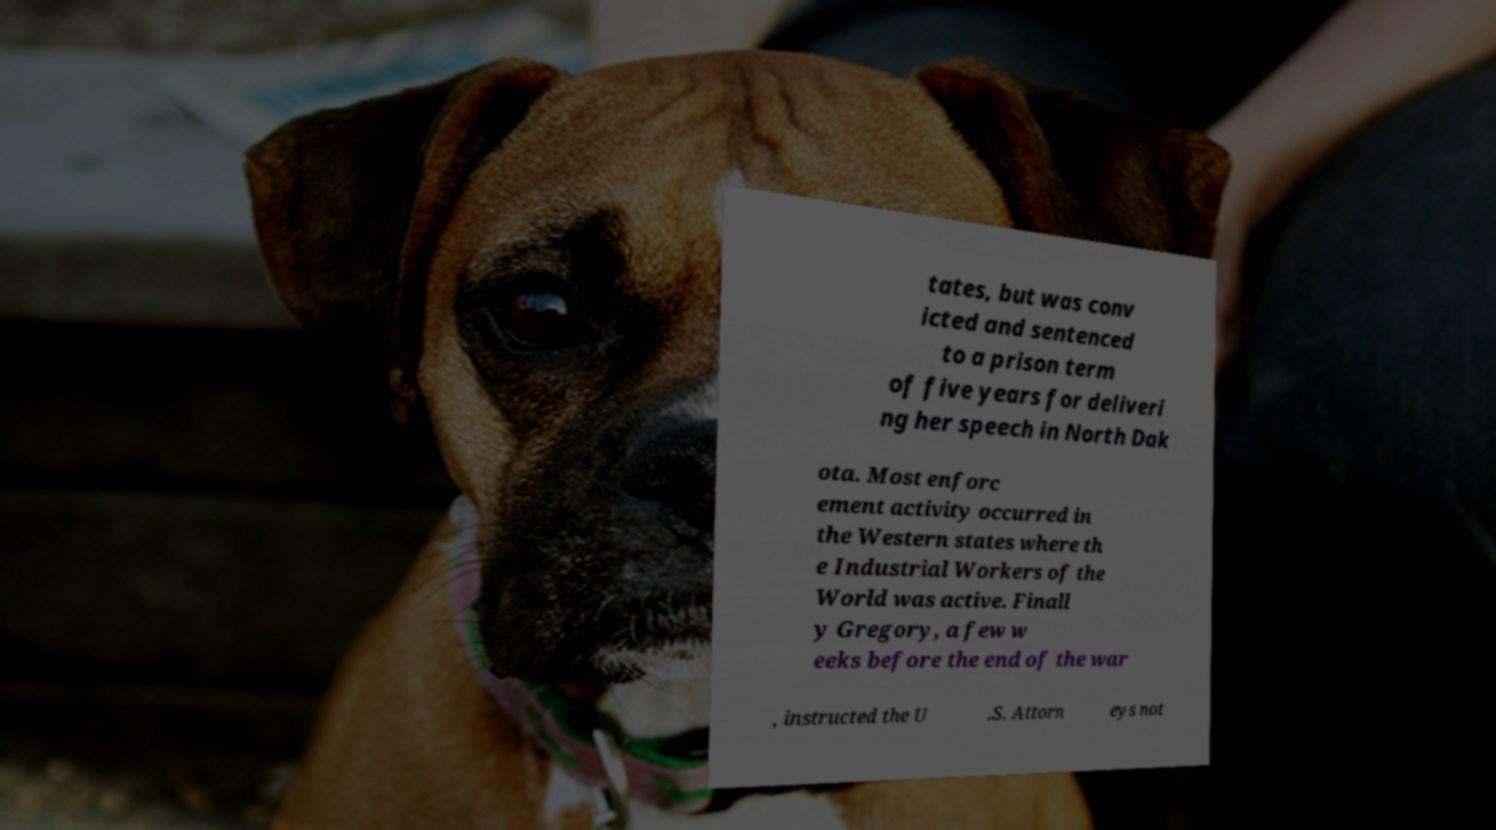Can you read and provide the text displayed in the image?This photo seems to have some interesting text. Can you extract and type it out for me? tates, but was conv icted and sentenced to a prison term of five years for deliveri ng her speech in North Dak ota. Most enforc ement activity occurred in the Western states where th e Industrial Workers of the World was active. Finall y Gregory, a few w eeks before the end of the war , instructed the U .S. Attorn eys not 